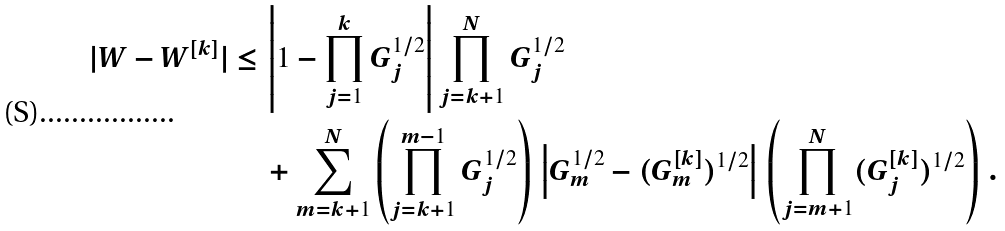<formula> <loc_0><loc_0><loc_500><loc_500>| W - W ^ { [ k ] } | \leq \, & \left | 1 - \prod _ { j = 1 } ^ { k } G _ { j } ^ { 1 / 2 } \right | \prod _ { j = k + 1 } ^ { N } G _ { j } ^ { 1 / 2 } \\ & + \sum _ { m = k + 1 } ^ { N } \left ( \prod _ { j = k + 1 } ^ { m - 1 } G _ { j } ^ { 1 / 2 } \right ) \, \left | G _ { m } ^ { 1 / 2 } - ( G _ { m } ^ { [ k ] } ) ^ { 1 / 2 } \right | \, \left ( \prod _ { j = m + 1 } ^ { N } ( G _ { j } ^ { [ k ] } ) ^ { 1 / 2 } \right ) \, .</formula> 